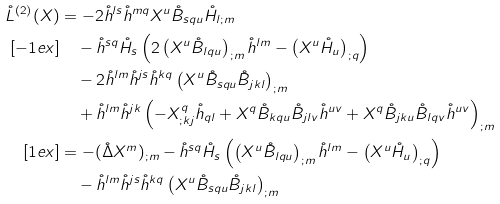Convert formula to latex. <formula><loc_0><loc_0><loc_500><loc_500>\mathring { L } ^ { ( 2 ) } ( X ) & = - 2 \mathring { h } ^ { l s } \mathring { h } ^ { m q } X ^ { u } \mathring { B } _ { s q u } \mathring { H } _ { l ; m } \\ [ - 1 e x ] & \quad - \mathring { h } ^ { s q } \mathring { H } _ { s } \left ( 2 \left ( X ^ { u } \mathring { B } _ { l q u } \right ) _ { ; m } \mathring { h } ^ { l m } - \left ( X ^ { u } \mathring { H } _ { u } \right ) _ { ; q } \right ) \\ & \quad - 2 \mathring { h } ^ { l m } \mathring { h } ^ { j s } \mathring { h } ^ { k q } \left ( X ^ { u } \mathring { B } _ { s q u } \mathring { B } _ { j k l } \right ) _ { ; m } \\ & \quad + \mathring { h } ^ { l m } \mathring { h } ^ { j k } \left ( - X ^ { q } _ { ; k j } \mathring { h } _ { q l } + X ^ { q } \mathring { B } _ { k q u } \mathring { B } _ { j l v } \mathring { h } ^ { u v } + X ^ { q } \mathring { B } _ { j k u } \mathring { B } _ { l q v } \mathring { h } ^ { u v } \right ) _ { ; m } \\ [ 1 e x ] & = - ( \mathring { \Delta } X ^ { m } ) _ { ; m } - \mathring { h } ^ { s q } \mathring { H } _ { s } \left ( \left ( X ^ { u } \mathring { B } _ { l q u } \right ) _ { ; m } \mathring { h } ^ { l m } - \left ( X ^ { u } \mathring { H } _ { u } \right ) _ { ; q } \right ) \\ & \quad - \mathring { h } ^ { l m } \mathring { h } ^ { j s } \mathring { h } ^ { k q } \left ( X ^ { u } \mathring { B } _ { s q u } \mathring { B } _ { j k l } \right ) _ { ; m }</formula> 